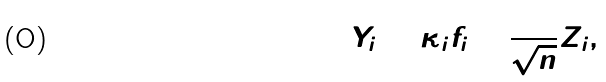<formula> <loc_0><loc_0><loc_500><loc_500>Y _ { i } = \kappa _ { i } f _ { i } + \frac { 1 } { \sqrt { n } } Z _ { i } ,</formula> 